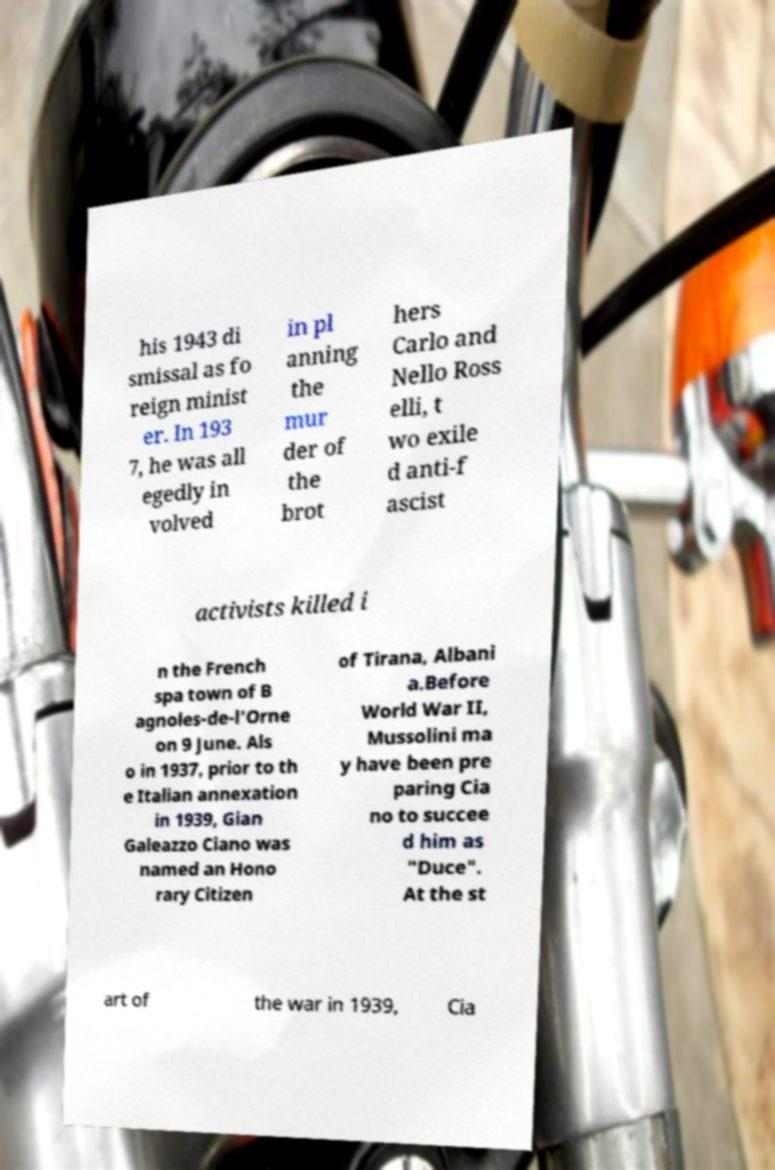What messages or text are displayed in this image? I need them in a readable, typed format. his 1943 di smissal as fo reign minist er. In 193 7, he was all egedly in volved in pl anning the mur der of the brot hers Carlo and Nello Ross elli, t wo exile d anti-f ascist activists killed i n the French spa town of B agnoles-de-l'Orne on 9 June. Als o in 1937, prior to th e Italian annexation in 1939, Gian Galeazzo Ciano was named an Hono rary Citizen of Tirana, Albani a.Before World War II, Mussolini ma y have been pre paring Cia no to succee d him as "Duce". At the st art of the war in 1939, Cia 